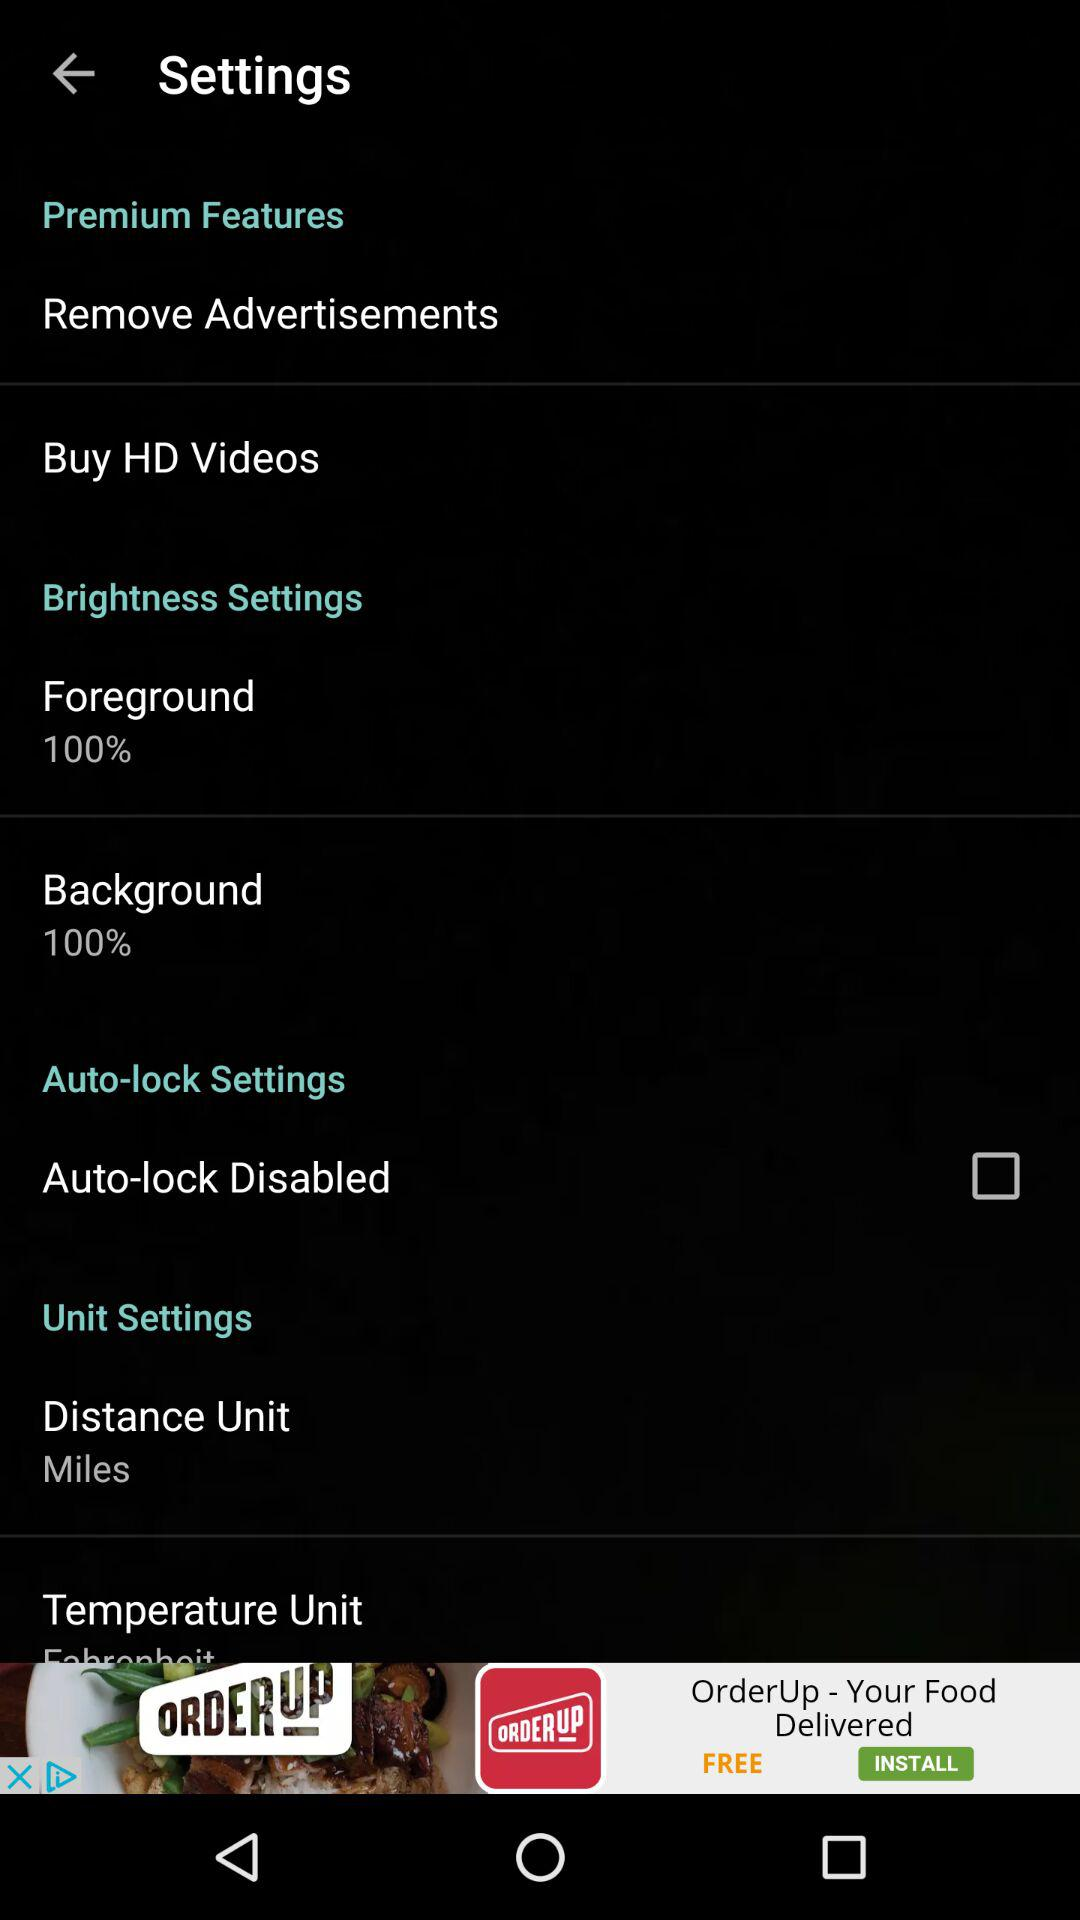What's the status of "Auto-lock Disabled"? The status of "Auto-lock Disabled" is "off". 